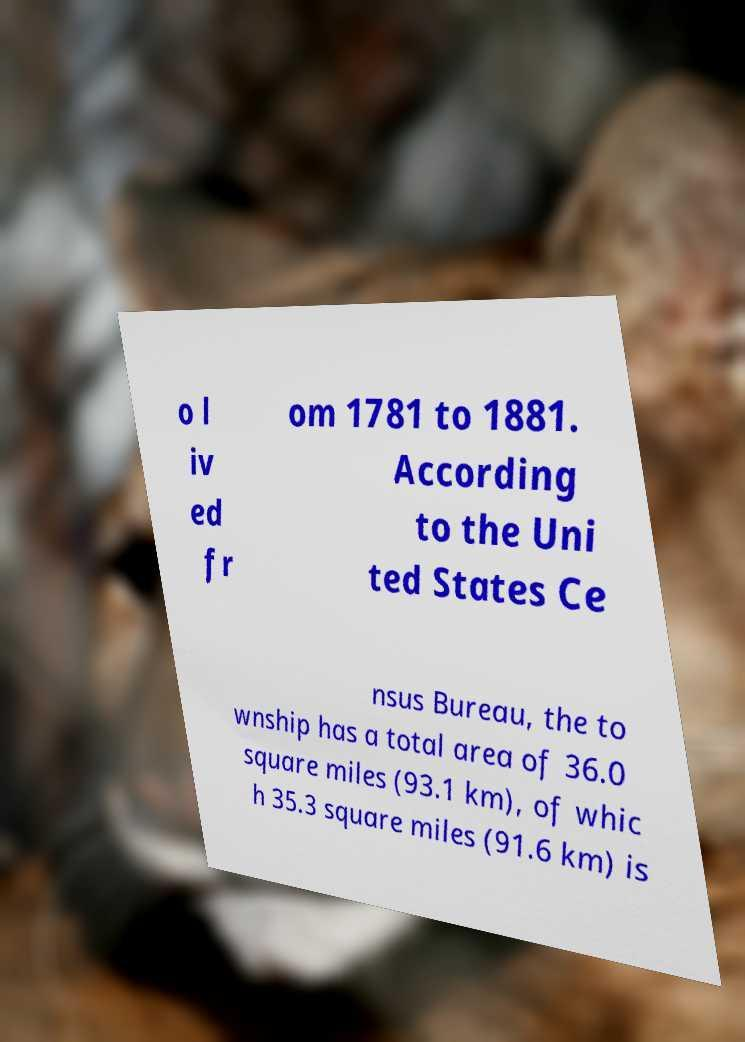There's text embedded in this image that I need extracted. Can you transcribe it verbatim? o l iv ed fr om 1781 to 1881. According to the Uni ted States Ce nsus Bureau, the to wnship has a total area of 36.0 square miles (93.1 km), of whic h 35.3 square miles (91.6 km) is 